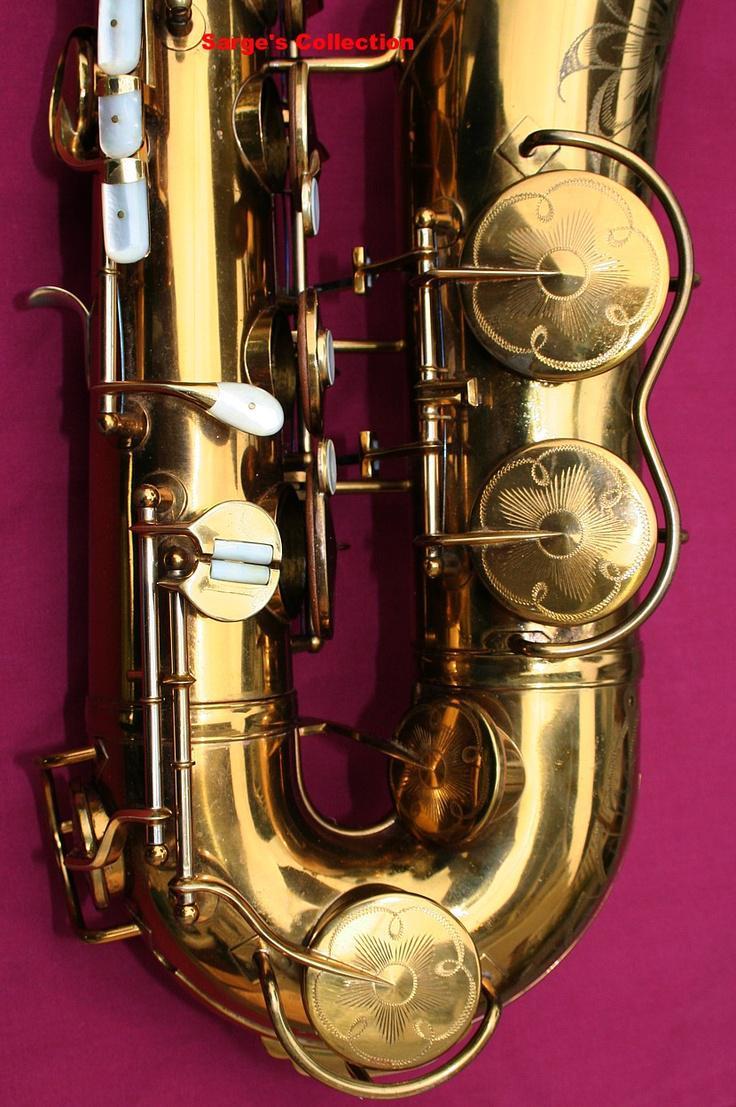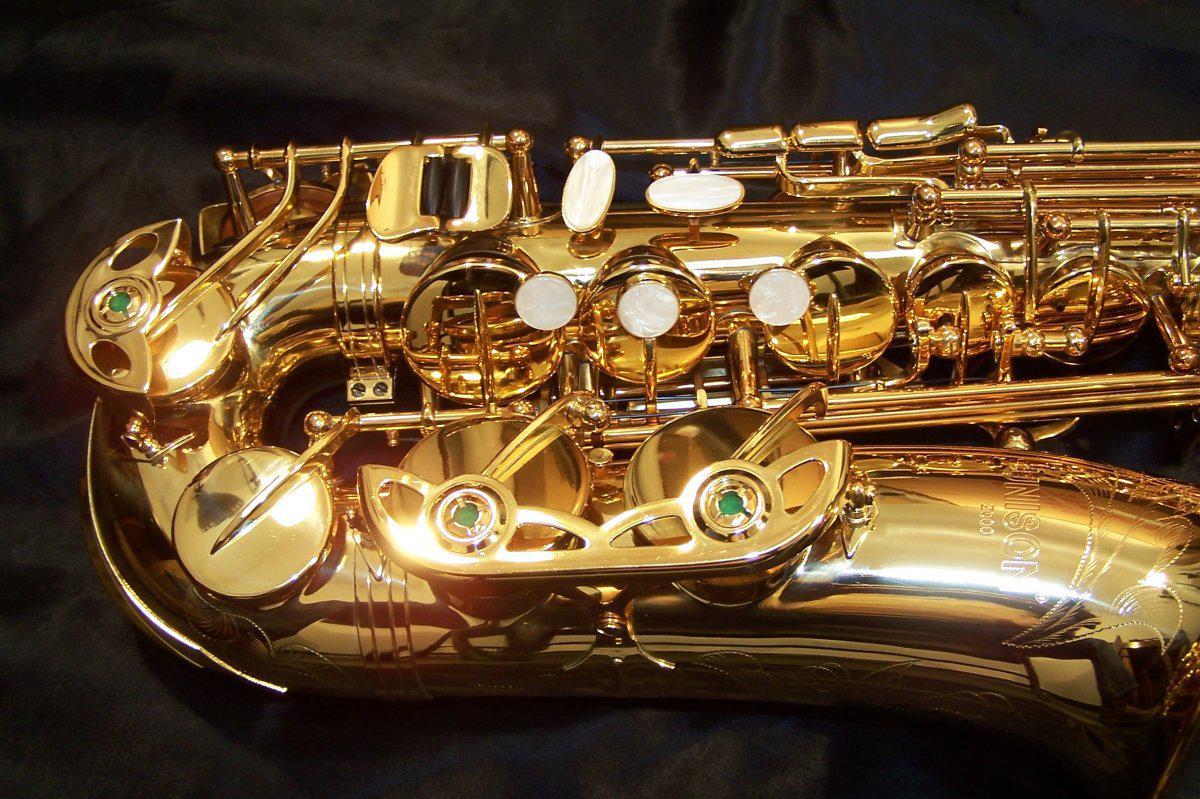The first image is the image on the left, the second image is the image on the right. Given the left and right images, does the statement "One image shows a single saxophone displayed nearly vertically, and one shows a saxophone displayed diagonally at about a 45-degree angle." hold true? Answer yes or no. No. The first image is the image on the left, the second image is the image on the right. Considering the images on both sides, is "All instruments on the left hand image are displayed vertically, while they are displayed horizontally or diagonally on the right hand images." valid? Answer yes or no. Yes. 